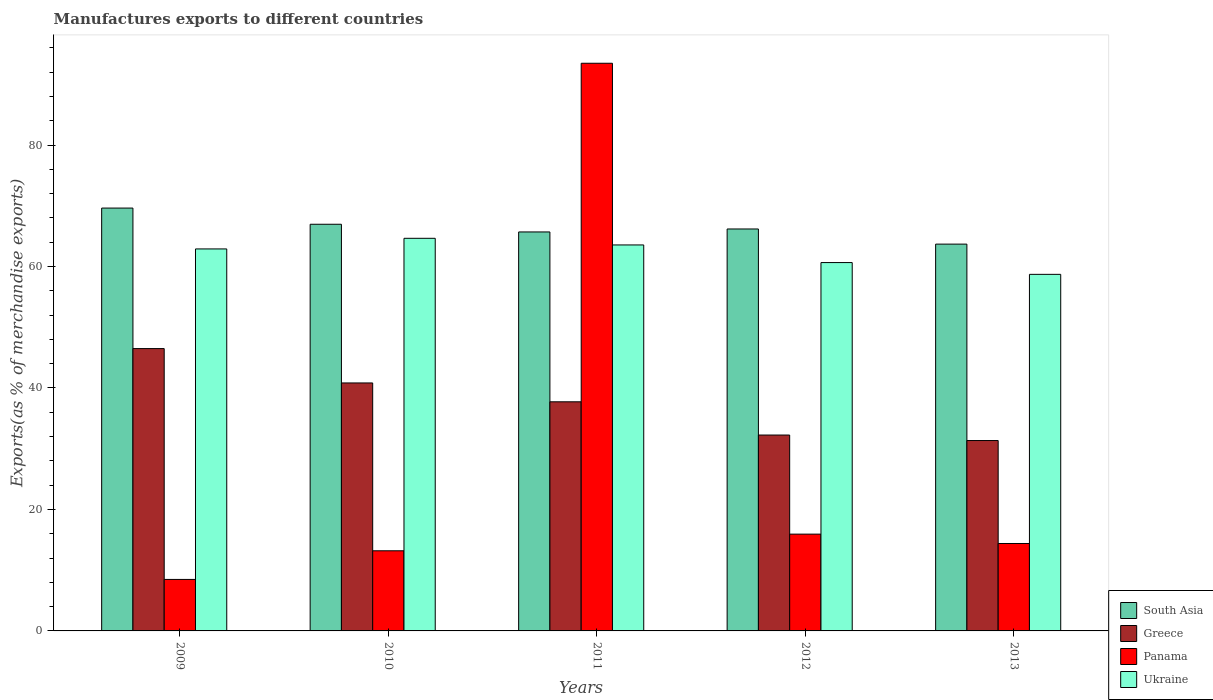How many different coloured bars are there?
Provide a short and direct response. 4. Are the number of bars per tick equal to the number of legend labels?
Offer a terse response. Yes. How many bars are there on the 1st tick from the right?
Give a very brief answer. 4. What is the label of the 2nd group of bars from the left?
Give a very brief answer. 2010. In how many cases, is the number of bars for a given year not equal to the number of legend labels?
Make the answer very short. 0. What is the percentage of exports to different countries in Greece in 2013?
Keep it short and to the point. 31.34. Across all years, what is the maximum percentage of exports to different countries in Panama?
Your answer should be very brief. 93.46. Across all years, what is the minimum percentage of exports to different countries in Panama?
Your response must be concise. 8.48. In which year was the percentage of exports to different countries in South Asia maximum?
Offer a terse response. 2009. What is the total percentage of exports to different countries in Ukraine in the graph?
Ensure brevity in your answer.  310.43. What is the difference between the percentage of exports to different countries in Greece in 2010 and that in 2011?
Your response must be concise. 3.1. What is the difference between the percentage of exports to different countries in Greece in 2011 and the percentage of exports to different countries in South Asia in 2010?
Your answer should be very brief. -29.23. What is the average percentage of exports to different countries in South Asia per year?
Your answer should be compact. 66.42. In the year 2012, what is the difference between the percentage of exports to different countries in Panama and percentage of exports to different countries in South Asia?
Make the answer very short. -50.24. What is the ratio of the percentage of exports to different countries in Greece in 2009 to that in 2013?
Your answer should be very brief. 1.48. Is the percentage of exports to different countries in Ukraine in 2009 less than that in 2010?
Give a very brief answer. Yes. What is the difference between the highest and the second highest percentage of exports to different countries in Greece?
Offer a very short reply. 5.66. What is the difference between the highest and the lowest percentage of exports to different countries in Greece?
Give a very brief answer. 15.14. In how many years, is the percentage of exports to different countries in Panama greater than the average percentage of exports to different countries in Panama taken over all years?
Offer a very short reply. 1. Is it the case that in every year, the sum of the percentage of exports to different countries in South Asia and percentage of exports to different countries in Greece is greater than the sum of percentage of exports to different countries in Panama and percentage of exports to different countries in Ukraine?
Your answer should be compact. No. What does the 3rd bar from the left in 2013 represents?
Provide a short and direct response. Panama. Is it the case that in every year, the sum of the percentage of exports to different countries in Panama and percentage of exports to different countries in Greece is greater than the percentage of exports to different countries in Ukraine?
Your answer should be very brief. No. Are all the bars in the graph horizontal?
Make the answer very short. No. How many years are there in the graph?
Your answer should be very brief. 5. Are the values on the major ticks of Y-axis written in scientific E-notation?
Provide a short and direct response. No. Does the graph contain grids?
Your response must be concise. No. Where does the legend appear in the graph?
Ensure brevity in your answer.  Bottom right. How many legend labels are there?
Give a very brief answer. 4. What is the title of the graph?
Offer a very short reply. Manufactures exports to different countries. What is the label or title of the Y-axis?
Your response must be concise. Exports(as % of merchandise exports). What is the Exports(as % of merchandise exports) in South Asia in 2009?
Provide a short and direct response. 69.62. What is the Exports(as % of merchandise exports) in Greece in 2009?
Ensure brevity in your answer.  46.48. What is the Exports(as % of merchandise exports) in Panama in 2009?
Your answer should be very brief. 8.48. What is the Exports(as % of merchandise exports) in Ukraine in 2009?
Your answer should be compact. 62.89. What is the Exports(as % of merchandise exports) of South Asia in 2010?
Your answer should be very brief. 66.95. What is the Exports(as % of merchandise exports) in Greece in 2010?
Give a very brief answer. 40.83. What is the Exports(as % of merchandise exports) in Panama in 2010?
Your answer should be very brief. 13.19. What is the Exports(as % of merchandise exports) in Ukraine in 2010?
Your answer should be very brief. 64.64. What is the Exports(as % of merchandise exports) of South Asia in 2011?
Your answer should be compact. 65.69. What is the Exports(as % of merchandise exports) in Greece in 2011?
Keep it short and to the point. 37.72. What is the Exports(as % of merchandise exports) of Panama in 2011?
Offer a very short reply. 93.46. What is the Exports(as % of merchandise exports) in Ukraine in 2011?
Your answer should be compact. 63.55. What is the Exports(as % of merchandise exports) of South Asia in 2012?
Your answer should be compact. 66.18. What is the Exports(as % of merchandise exports) of Greece in 2012?
Offer a very short reply. 32.25. What is the Exports(as % of merchandise exports) of Panama in 2012?
Your response must be concise. 15.93. What is the Exports(as % of merchandise exports) of Ukraine in 2012?
Provide a succinct answer. 60.65. What is the Exports(as % of merchandise exports) of South Asia in 2013?
Your answer should be very brief. 63.68. What is the Exports(as % of merchandise exports) in Greece in 2013?
Offer a very short reply. 31.34. What is the Exports(as % of merchandise exports) in Panama in 2013?
Your response must be concise. 14.39. What is the Exports(as % of merchandise exports) of Ukraine in 2013?
Provide a succinct answer. 58.71. Across all years, what is the maximum Exports(as % of merchandise exports) of South Asia?
Provide a short and direct response. 69.62. Across all years, what is the maximum Exports(as % of merchandise exports) in Greece?
Ensure brevity in your answer.  46.48. Across all years, what is the maximum Exports(as % of merchandise exports) of Panama?
Ensure brevity in your answer.  93.46. Across all years, what is the maximum Exports(as % of merchandise exports) of Ukraine?
Offer a very short reply. 64.64. Across all years, what is the minimum Exports(as % of merchandise exports) in South Asia?
Keep it short and to the point. 63.68. Across all years, what is the minimum Exports(as % of merchandise exports) of Greece?
Ensure brevity in your answer.  31.34. Across all years, what is the minimum Exports(as % of merchandise exports) in Panama?
Keep it short and to the point. 8.48. Across all years, what is the minimum Exports(as % of merchandise exports) of Ukraine?
Keep it short and to the point. 58.71. What is the total Exports(as % of merchandise exports) of South Asia in the graph?
Your response must be concise. 332.12. What is the total Exports(as % of merchandise exports) in Greece in the graph?
Offer a very short reply. 188.63. What is the total Exports(as % of merchandise exports) of Panama in the graph?
Offer a terse response. 145.46. What is the total Exports(as % of merchandise exports) of Ukraine in the graph?
Your answer should be very brief. 310.43. What is the difference between the Exports(as % of merchandise exports) of South Asia in 2009 and that in 2010?
Make the answer very short. 2.66. What is the difference between the Exports(as % of merchandise exports) in Greece in 2009 and that in 2010?
Offer a very short reply. 5.66. What is the difference between the Exports(as % of merchandise exports) in Panama in 2009 and that in 2010?
Offer a very short reply. -4.71. What is the difference between the Exports(as % of merchandise exports) of Ukraine in 2009 and that in 2010?
Provide a succinct answer. -1.75. What is the difference between the Exports(as % of merchandise exports) in South Asia in 2009 and that in 2011?
Provide a short and direct response. 3.93. What is the difference between the Exports(as % of merchandise exports) of Greece in 2009 and that in 2011?
Your answer should be very brief. 8.76. What is the difference between the Exports(as % of merchandise exports) of Panama in 2009 and that in 2011?
Make the answer very short. -84.98. What is the difference between the Exports(as % of merchandise exports) of Ukraine in 2009 and that in 2011?
Your answer should be compact. -0.66. What is the difference between the Exports(as % of merchandise exports) in South Asia in 2009 and that in 2012?
Keep it short and to the point. 3.44. What is the difference between the Exports(as % of merchandise exports) of Greece in 2009 and that in 2012?
Provide a short and direct response. 14.23. What is the difference between the Exports(as % of merchandise exports) in Panama in 2009 and that in 2012?
Your response must be concise. -7.46. What is the difference between the Exports(as % of merchandise exports) of Ukraine in 2009 and that in 2012?
Your answer should be very brief. 2.25. What is the difference between the Exports(as % of merchandise exports) of South Asia in 2009 and that in 2013?
Make the answer very short. 5.93. What is the difference between the Exports(as % of merchandise exports) in Greece in 2009 and that in 2013?
Your answer should be compact. 15.14. What is the difference between the Exports(as % of merchandise exports) in Panama in 2009 and that in 2013?
Make the answer very short. -5.92. What is the difference between the Exports(as % of merchandise exports) of Ukraine in 2009 and that in 2013?
Your answer should be very brief. 4.19. What is the difference between the Exports(as % of merchandise exports) of South Asia in 2010 and that in 2011?
Your answer should be compact. 1.27. What is the difference between the Exports(as % of merchandise exports) in Greece in 2010 and that in 2011?
Provide a succinct answer. 3.1. What is the difference between the Exports(as % of merchandise exports) in Panama in 2010 and that in 2011?
Provide a short and direct response. -80.27. What is the difference between the Exports(as % of merchandise exports) of Ukraine in 2010 and that in 2011?
Offer a terse response. 1.09. What is the difference between the Exports(as % of merchandise exports) in South Asia in 2010 and that in 2012?
Ensure brevity in your answer.  0.78. What is the difference between the Exports(as % of merchandise exports) of Greece in 2010 and that in 2012?
Ensure brevity in your answer.  8.58. What is the difference between the Exports(as % of merchandise exports) in Panama in 2010 and that in 2012?
Ensure brevity in your answer.  -2.74. What is the difference between the Exports(as % of merchandise exports) of Ukraine in 2010 and that in 2012?
Give a very brief answer. 3.99. What is the difference between the Exports(as % of merchandise exports) in South Asia in 2010 and that in 2013?
Your response must be concise. 3.27. What is the difference between the Exports(as % of merchandise exports) in Greece in 2010 and that in 2013?
Offer a very short reply. 9.48. What is the difference between the Exports(as % of merchandise exports) of Panama in 2010 and that in 2013?
Offer a terse response. -1.2. What is the difference between the Exports(as % of merchandise exports) of Ukraine in 2010 and that in 2013?
Your answer should be compact. 5.93. What is the difference between the Exports(as % of merchandise exports) of South Asia in 2011 and that in 2012?
Your answer should be very brief. -0.49. What is the difference between the Exports(as % of merchandise exports) of Greece in 2011 and that in 2012?
Offer a very short reply. 5.47. What is the difference between the Exports(as % of merchandise exports) of Panama in 2011 and that in 2012?
Provide a succinct answer. 77.53. What is the difference between the Exports(as % of merchandise exports) of Ukraine in 2011 and that in 2012?
Keep it short and to the point. 2.9. What is the difference between the Exports(as % of merchandise exports) in South Asia in 2011 and that in 2013?
Provide a short and direct response. 2. What is the difference between the Exports(as % of merchandise exports) of Greece in 2011 and that in 2013?
Give a very brief answer. 6.38. What is the difference between the Exports(as % of merchandise exports) in Panama in 2011 and that in 2013?
Your answer should be very brief. 79.07. What is the difference between the Exports(as % of merchandise exports) in Ukraine in 2011 and that in 2013?
Give a very brief answer. 4.84. What is the difference between the Exports(as % of merchandise exports) in South Asia in 2012 and that in 2013?
Your answer should be very brief. 2.49. What is the difference between the Exports(as % of merchandise exports) of Greece in 2012 and that in 2013?
Offer a very short reply. 0.91. What is the difference between the Exports(as % of merchandise exports) in Panama in 2012 and that in 2013?
Offer a terse response. 1.54. What is the difference between the Exports(as % of merchandise exports) in Ukraine in 2012 and that in 2013?
Ensure brevity in your answer.  1.94. What is the difference between the Exports(as % of merchandise exports) in South Asia in 2009 and the Exports(as % of merchandise exports) in Greece in 2010?
Ensure brevity in your answer.  28.79. What is the difference between the Exports(as % of merchandise exports) of South Asia in 2009 and the Exports(as % of merchandise exports) of Panama in 2010?
Ensure brevity in your answer.  56.43. What is the difference between the Exports(as % of merchandise exports) of South Asia in 2009 and the Exports(as % of merchandise exports) of Ukraine in 2010?
Your answer should be very brief. 4.98. What is the difference between the Exports(as % of merchandise exports) in Greece in 2009 and the Exports(as % of merchandise exports) in Panama in 2010?
Provide a succinct answer. 33.29. What is the difference between the Exports(as % of merchandise exports) of Greece in 2009 and the Exports(as % of merchandise exports) of Ukraine in 2010?
Make the answer very short. -18.16. What is the difference between the Exports(as % of merchandise exports) of Panama in 2009 and the Exports(as % of merchandise exports) of Ukraine in 2010?
Your answer should be very brief. -56.16. What is the difference between the Exports(as % of merchandise exports) in South Asia in 2009 and the Exports(as % of merchandise exports) in Greece in 2011?
Give a very brief answer. 31.89. What is the difference between the Exports(as % of merchandise exports) of South Asia in 2009 and the Exports(as % of merchandise exports) of Panama in 2011?
Offer a very short reply. -23.84. What is the difference between the Exports(as % of merchandise exports) in South Asia in 2009 and the Exports(as % of merchandise exports) in Ukraine in 2011?
Keep it short and to the point. 6.07. What is the difference between the Exports(as % of merchandise exports) of Greece in 2009 and the Exports(as % of merchandise exports) of Panama in 2011?
Your answer should be very brief. -46.98. What is the difference between the Exports(as % of merchandise exports) of Greece in 2009 and the Exports(as % of merchandise exports) of Ukraine in 2011?
Ensure brevity in your answer.  -17.06. What is the difference between the Exports(as % of merchandise exports) of Panama in 2009 and the Exports(as % of merchandise exports) of Ukraine in 2011?
Offer a terse response. -55.07. What is the difference between the Exports(as % of merchandise exports) in South Asia in 2009 and the Exports(as % of merchandise exports) in Greece in 2012?
Keep it short and to the point. 37.37. What is the difference between the Exports(as % of merchandise exports) in South Asia in 2009 and the Exports(as % of merchandise exports) in Panama in 2012?
Keep it short and to the point. 53.68. What is the difference between the Exports(as % of merchandise exports) of South Asia in 2009 and the Exports(as % of merchandise exports) of Ukraine in 2012?
Offer a terse response. 8.97. What is the difference between the Exports(as % of merchandise exports) of Greece in 2009 and the Exports(as % of merchandise exports) of Panama in 2012?
Ensure brevity in your answer.  30.55. What is the difference between the Exports(as % of merchandise exports) in Greece in 2009 and the Exports(as % of merchandise exports) in Ukraine in 2012?
Give a very brief answer. -14.16. What is the difference between the Exports(as % of merchandise exports) of Panama in 2009 and the Exports(as % of merchandise exports) of Ukraine in 2012?
Provide a succinct answer. -52.17. What is the difference between the Exports(as % of merchandise exports) in South Asia in 2009 and the Exports(as % of merchandise exports) in Greece in 2013?
Provide a succinct answer. 38.27. What is the difference between the Exports(as % of merchandise exports) in South Asia in 2009 and the Exports(as % of merchandise exports) in Panama in 2013?
Make the answer very short. 55.22. What is the difference between the Exports(as % of merchandise exports) of South Asia in 2009 and the Exports(as % of merchandise exports) of Ukraine in 2013?
Offer a very short reply. 10.91. What is the difference between the Exports(as % of merchandise exports) of Greece in 2009 and the Exports(as % of merchandise exports) of Panama in 2013?
Offer a terse response. 32.09. What is the difference between the Exports(as % of merchandise exports) of Greece in 2009 and the Exports(as % of merchandise exports) of Ukraine in 2013?
Keep it short and to the point. -12.22. What is the difference between the Exports(as % of merchandise exports) in Panama in 2009 and the Exports(as % of merchandise exports) in Ukraine in 2013?
Your response must be concise. -50.23. What is the difference between the Exports(as % of merchandise exports) of South Asia in 2010 and the Exports(as % of merchandise exports) of Greece in 2011?
Provide a succinct answer. 29.23. What is the difference between the Exports(as % of merchandise exports) in South Asia in 2010 and the Exports(as % of merchandise exports) in Panama in 2011?
Offer a terse response. -26.51. What is the difference between the Exports(as % of merchandise exports) in South Asia in 2010 and the Exports(as % of merchandise exports) in Ukraine in 2011?
Provide a short and direct response. 3.41. What is the difference between the Exports(as % of merchandise exports) of Greece in 2010 and the Exports(as % of merchandise exports) of Panama in 2011?
Ensure brevity in your answer.  -52.63. What is the difference between the Exports(as % of merchandise exports) of Greece in 2010 and the Exports(as % of merchandise exports) of Ukraine in 2011?
Your answer should be compact. -22.72. What is the difference between the Exports(as % of merchandise exports) of Panama in 2010 and the Exports(as % of merchandise exports) of Ukraine in 2011?
Offer a very short reply. -50.36. What is the difference between the Exports(as % of merchandise exports) of South Asia in 2010 and the Exports(as % of merchandise exports) of Greece in 2012?
Offer a very short reply. 34.7. What is the difference between the Exports(as % of merchandise exports) in South Asia in 2010 and the Exports(as % of merchandise exports) in Panama in 2012?
Ensure brevity in your answer.  51.02. What is the difference between the Exports(as % of merchandise exports) of South Asia in 2010 and the Exports(as % of merchandise exports) of Ukraine in 2012?
Ensure brevity in your answer.  6.31. What is the difference between the Exports(as % of merchandise exports) in Greece in 2010 and the Exports(as % of merchandise exports) in Panama in 2012?
Keep it short and to the point. 24.89. What is the difference between the Exports(as % of merchandise exports) of Greece in 2010 and the Exports(as % of merchandise exports) of Ukraine in 2012?
Offer a very short reply. -19.82. What is the difference between the Exports(as % of merchandise exports) in Panama in 2010 and the Exports(as % of merchandise exports) in Ukraine in 2012?
Your response must be concise. -47.45. What is the difference between the Exports(as % of merchandise exports) in South Asia in 2010 and the Exports(as % of merchandise exports) in Greece in 2013?
Your answer should be very brief. 35.61. What is the difference between the Exports(as % of merchandise exports) of South Asia in 2010 and the Exports(as % of merchandise exports) of Panama in 2013?
Your answer should be compact. 52.56. What is the difference between the Exports(as % of merchandise exports) in South Asia in 2010 and the Exports(as % of merchandise exports) in Ukraine in 2013?
Your answer should be compact. 8.25. What is the difference between the Exports(as % of merchandise exports) in Greece in 2010 and the Exports(as % of merchandise exports) in Panama in 2013?
Offer a terse response. 26.43. What is the difference between the Exports(as % of merchandise exports) of Greece in 2010 and the Exports(as % of merchandise exports) of Ukraine in 2013?
Provide a short and direct response. -17.88. What is the difference between the Exports(as % of merchandise exports) of Panama in 2010 and the Exports(as % of merchandise exports) of Ukraine in 2013?
Keep it short and to the point. -45.51. What is the difference between the Exports(as % of merchandise exports) in South Asia in 2011 and the Exports(as % of merchandise exports) in Greece in 2012?
Give a very brief answer. 33.44. What is the difference between the Exports(as % of merchandise exports) of South Asia in 2011 and the Exports(as % of merchandise exports) of Panama in 2012?
Provide a succinct answer. 49.75. What is the difference between the Exports(as % of merchandise exports) of South Asia in 2011 and the Exports(as % of merchandise exports) of Ukraine in 2012?
Give a very brief answer. 5.04. What is the difference between the Exports(as % of merchandise exports) of Greece in 2011 and the Exports(as % of merchandise exports) of Panama in 2012?
Make the answer very short. 21.79. What is the difference between the Exports(as % of merchandise exports) of Greece in 2011 and the Exports(as % of merchandise exports) of Ukraine in 2012?
Provide a short and direct response. -22.92. What is the difference between the Exports(as % of merchandise exports) in Panama in 2011 and the Exports(as % of merchandise exports) in Ukraine in 2012?
Provide a succinct answer. 32.81. What is the difference between the Exports(as % of merchandise exports) of South Asia in 2011 and the Exports(as % of merchandise exports) of Greece in 2013?
Your answer should be compact. 34.34. What is the difference between the Exports(as % of merchandise exports) in South Asia in 2011 and the Exports(as % of merchandise exports) in Panama in 2013?
Your answer should be compact. 51.29. What is the difference between the Exports(as % of merchandise exports) in South Asia in 2011 and the Exports(as % of merchandise exports) in Ukraine in 2013?
Keep it short and to the point. 6.98. What is the difference between the Exports(as % of merchandise exports) of Greece in 2011 and the Exports(as % of merchandise exports) of Panama in 2013?
Ensure brevity in your answer.  23.33. What is the difference between the Exports(as % of merchandise exports) of Greece in 2011 and the Exports(as % of merchandise exports) of Ukraine in 2013?
Your answer should be very brief. -20.98. What is the difference between the Exports(as % of merchandise exports) in Panama in 2011 and the Exports(as % of merchandise exports) in Ukraine in 2013?
Your answer should be compact. 34.75. What is the difference between the Exports(as % of merchandise exports) in South Asia in 2012 and the Exports(as % of merchandise exports) in Greece in 2013?
Your answer should be compact. 34.83. What is the difference between the Exports(as % of merchandise exports) of South Asia in 2012 and the Exports(as % of merchandise exports) of Panama in 2013?
Your answer should be very brief. 51.78. What is the difference between the Exports(as % of merchandise exports) of South Asia in 2012 and the Exports(as % of merchandise exports) of Ukraine in 2013?
Your answer should be compact. 7.47. What is the difference between the Exports(as % of merchandise exports) of Greece in 2012 and the Exports(as % of merchandise exports) of Panama in 2013?
Your response must be concise. 17.86. What is the difference between the Exports(as % of merchandise exports) in Greece in 2012 and the Exports(as % of merchandise exports) in Ukraine in 2013?
Offer a terse response. -26.46. What is the difference between the Exports(as % of merchandise exports) in Panama in 2012 and the Exports(as % of merchandise exports) in Ukraine in 2013?
Offer a terse response. -42.77. What is the average Exports(as % of merchandise exports) in South Asia per year?
Your answer should be compact. 66.42. What is the average Exports(as % of merchandise exports) of Greece per year?
Your answer should be very brief. 37.73. What is the average Exports(as % of merchandise exports) of Panama per year?
Provide a succinct answer. 29.09. What is the average Exports(as % of merchandise exports) of Ukraine per year?
Your answer should be very brief. 62.09. In the year 2009, what is the difference between the Exports(as % of merchandise exports) in South Asia and Exports(as % of merchandise exports) in Greece?
Provide a short and direct response. 23.13. In the year 2009, what is the difference between the Exports(as % of merchandise exports) in South Asia and Exports(as % of merchandise exports) in Panama?
Offer a very short reply. 61.14. In the year 2009, what is the difference between the Exports(as % of merchandise exports) of South Asia and Exports(as % of merchandise exports) of Ukraine?
Offer a very short reply. 6.73. In the year 2009, what is the difference between the Exports(as % of merchandise exports) of Greece and Exports(as % of merchandise exports) of Panama?
Provide a succinct answer. 38.01. In the year 2009, what is the difference between the Exports(as % of merchandise exports) of Greece and Exports(as % of merchandise exports) of Ukraine?
Give a very brief answer. -16.41. In the year 2009, what is the difference between the Exports(as % of merchandise exports) of Panama and Exports(as % of merchandise exports) of Ukraine?
Keep it short and to the point. -54.41. In the year 2010, what is the difference between the Exports(as % of merchandise exports) of South Asia and Exports(as % of merchandise exports) of Greece?
Make the answer very short. 26.13. In the year 2010, what is the difference between the Exports(as % of merchandise exports) in South Asia and Exports(as % of merchandise exports) in Panama?
Make the answer very short. 53.76. In the year 2010, what is the difference between the Exports(as % of merchandise exports) in South Asia and Exports(as % of merchandise exports) in Ukraine?
Provide a short and direct response. 2.31. In the year 2010, what is the difference between the Exports(as % of merchandise exports) in Greece and Exports(as % of merchandise exports) in Panama?
Provide a short and direct response. 27.63. In the year 2010, what is the difference between the Exports(as % of merchandise exports) in Greece and Exports(as % of merchandise exports) in Ukraine?
Give a very brief answer. -23.82. In the year 2010, what is the difference between the Exports(as % of merchandise exports) in Panama and Exports(as % of merchandise exports) in Ukraine?
Keep it short and to the point. -51.45. In the year 2011, what is the difference between the Exports(as % of merchandise exports) in South Asia and Exports(as % of merchandise exports) in Greece?
Offer a very short reply. 27.96. In the year 2011, what is the difference between the Exports(as % of merchandise exports) in South Asia and Exports(as % of merchandise exports) in Panama?
Give a very brief answer. -27.77. In the year 2011, what is the difference between the Exports(as % of merchandise exports) of South Asia and Exports(as % of merchandise exports) of Ukraine?
Give a very brief answer. 2.14. In the year 2011, what is the difference between the Exports(as % of merchandise exports) of Greece and Exports(as % of merchandise exports) of Panama?
Give a very brief answer. -55.74. In the year 2011, what is the difference between the Exports(as % of merchandise exports) in Greece and Exports(as % of merchandise exports) in Ukraine?
Your answer should be very brief. -25.82. In the year 2011, what is the difference between the Exports(as % of merchandise exports) in Panama and Exports(as % of merchandise exports) in Ukraine?
Keep it short and to the point. 29.91. In the year 2012, what is the difference between the Exports(as % of merchandise exports) of South Asia and Exports(as % of merchandise exports) of Greece?
Your answer should be very brief. 33.93. In the year 2012, what is the difference between the Exports(as % of merchandise exports) of South Asia and Exports(as % of merchandise exports) of Panama?
Make the answer very short. 50.24. In the year 2012, what is the difference between the Exports(as % of merchandise exports) in South Asia and Exports(as % of merchandise exports) in Ukraine?
Ensure brevity in your answer.  5.53. In the year 2012, what is the difference between the Exports(as % of merchandise exports) of Greece and Exports(as % of merchandise exports) of Panama?
Offer a very short reply. 16.32. In the year 2012, what is the difference between the Exports(as % of merchandise exports) in Greece and Exports(as % of merchandise exports) in Ukraine?
Your response must be concise. -28.4. In the year 2012, what is the difference between the Exports(as % of merchandise exports) of Panama and Exports(as % of merchandise exports) of Ukraine?
Make the answer very short. -44.71. In the year 2013, what is the difference between the Exports(as % of merchandise exports) of South Asia and Exports(as % of merchandise exports) of Greece?
Ensure brevity in your answer.  32.34. In the year 2013, what is the difference between the Exports(as % of merchandise exports) of South Asia and Exports(as % of merchandise exports) of Panama?
Provide a succinct answer. 49.29. In the year 2013, what is the difference between the Exports(as % of merchandise exports) of South Asia and Exports(as % of merchandise exports) of Ukraine?
Keep it short and to the point. 4.98. In the year 2013, what is the difference between the Exports(as % of merchandise exports) in Greece and Exports(as % of merchandise exports) in Panama?
Provide a succinct answer. 16.95. In the year 2013, what is the difference between the Exports(as % of merchandise exports) of Greece and Exports(as % of merchandise exports) of Ukraine?
Keep it short and to the point. -27.36. In the year 2013, what is the difference between the Exports(as % of merchandise exports) in Panama and Exports(as % of merchandise exports) in Ukraine?
Provide a succinct answer. -44.31. What is the ratio of the Exports(as % of merchandise exports) of South Asia in 2009 to that in 2010?
Your answer should be compact. 1.04. What is the ratio of the Exports(as % of merchandise exports) in Greece in 2009 to that in 2010?
Your response must be concise. 1.14. What is the ratio of the Exports(as % of merchandise exports) of Panama in 2009 to that in 2010?
Provide a succinct answer. 0.64. What is the ratio of the Exports(as % of merchandise exports) of Ukraine in 2009 to that in 2010?
Ensure brevity in your answer.  0.97. What is the ratio of the Exports(as % of merchandise exports) in South Asia in 2009 to that in 2011?
Keep it short and to the point. 1.06. What is the ratio of the Exports(as % of merchandise exports) in Greece in 2009 to that in 2011?
Your response must be concise. 1.23. What is the ratio of the Exports(as % of merchandise exports) of Panama in 2009 to that in 2011?
Give a very brief answer. 0.09. What is the ratio of the Exports(as % of merchandise exports) in South Asia in 2009 to that in 2012?
Give a very brief answer. 1.05. What is the ratio of the Exports(as % of merchandise exports) of Greece in 2009 to that in 2012?
Offer a terse response. 1.44. What is the ratio of the Exports(as % of merchandise exports) of Panama in 2009 to that in 2012?
Give a very brief answer. 0.53. What is the ratio of the Exports(as % of merchandise exports) in Ukraine in 2009 to that in 2012?
Your answer should be compact. 1.04. What is the ratio of the Exports(as % of merchandise exports) in South Asia in 2009 to that in 2013?
Offer a terse response. 1.09. What is the ratio of the Exports(as % of merchandise exports) in Greece in 2009 to that in 2013?
Your answer should be very brief. 1.48. What is the ratio of the Exports(as % of merchandise exports) in Panama in 2009 to that in 2013?
Offer a very short reply. 0.59. What is the ratio of the Exports(as % of merchandise exports) of Ukraine in 2009 to that in 2013?
Your answer should be very brief. 1.07. What is the ratio of the Exports(as % of merchandise exports) of South Asia in 2010 to that in 2011?
Ensure brevity in your answer.  1.02. What is the ratio of the Exports(as % of merchandise exports) of Greece in 2010 to that in 2011?
Ensure brevity in your answer.  1.08. What is the ratio of the Exports(as % of merchandise exports) in Panama in 2010 to that in 2011?
Your response must be concise. 0.14. What is the ratio of the Exports(as % of merchandise exports) of Ukraine in 2010 to that in 2011?
Provide a short and direct response. 1.02. What is the ratio of the Exports(as % of merchandise exports) of South Asia in 2010 to that in 2012?
Your response must be concise. 1.01. What is the ratio of the Exports(as % of merchandise exports) of Greece in 2010 to that in 2012?
Provide a short and direct response. 1.27. What is the ratio of the Exports(as % of merchandise exports) of Panama in 2010 to that in 2012?
Ensure brevity in your answer.  0.83. What is the ratio of the Exports(as % of merchandise exports) of Ukraine in 2010 to that in 2012?
Provide a short and direct response. 1.07. What is the ratio of the Exports(as % of merchandise exports) of South Asia in 2010 to that in 2013?
Keep it short and to the point. 1.05. What is the ratio of the Exports(as % of merchandise exports) in Greece in 2010 to that in 2013?
Provide a short and direct response. 1.3. What is the ratio of the Exports(as % of merchandise exports) in Panama in 2010 to that in 2013?
Offer a terse response. 0.92. What is the ratio of the Exports(as % of merchandise exports) of Ukraine in 2010 to that in 2013?
Give a very brief answer. 1.1. What is the ratio of the Exports(as % of merchandise exports) of South Asia in 2011 to that in 2012?
Your answer should be very brief. 0.99. What is the ratio of the Exports(as % of merchandise exports) of Greece in 2011 to that in 2012?
Offer a terse response. 1.17. What is the ratio of the Exports(as % of merchandise exports) in Panama in 2011 to that in 2012?
Offer a very short reply. 5.87. What is the ratio of the Exports(as % of merchandise exports) of Ukraine in 2011 to that in 2012?
Ensure brevity in your answer.  1.05. What is the ratio of the Exports(as % of merchandise exports) in South Asia in 2011 to that in 2013?
Provide a succinct answer. 1.03. What is the ratio of the Exports(as % of merchandise exports) in Greece in 2011 to that in 2013?
Give a very brief answer. 1.2. What is the ratio of the Exports(as % of merchandise exports) of Panama in 2011 to that in 2013?
Your response must be concise. 6.49. What is the ratio of the Exports(as % of merchandise exports) of Ukraine in 2011 to that in 2013?
Make the answer very short. 1.08. What is the ratio of the Exports(as % of merchandise exports) in South Asia in 2012 to that in 2013?
Offer a terse response. 1.04. What is the ratio of the Exports(as % of merchandise exports) of Greece in 2012 to that in 2013?
Ensure brevity in your answer.  1.03. What is the ratio of the Exports(as % of merchandise exports) of Panama in 2012 to that in 2013?
Give a very brief answer. 1.11. What is the ratio of the Exports(as % of merchandise exports) in Ukraine in 2012 to that in 2013?
Offer a terse response. 1.03. What is the difference between the highest and the second highest Exports(as % of merchandise exports) of South Asia?
Your response must be concise. 2.66. What is the difference between the highest and the second highest Exports(as % of merchandise exports) in Greece?
Give a very brief answer. 5.66. What is the difference between the highest and the second highest Exports(as % of merchandise exports) in Panama?
Make the answer very short. 77.53. What is the difference between the highest and the second highest Exports(as % of merchandise exports) in Ukraine?
Your response must be concise. 1.09. What is the difference between the highest and the lowest Exports(as % of merchandise exports) in South Asia?
Provide a short and direct response. 5.93. What is the difference between the highest and the lowest Exports(as % of merchandise exports) in Greece?
Your answer should be compact. 15.14. What is the difference between the highest and the lowest Exports(as % of merchandise exports) in Panama?
Your answer should be compact. 84.98. What is the difference between the highest and the lowest Exports(as % of merchandise exports) of Ukraine?
Provide a short and direct response. 5.93. 